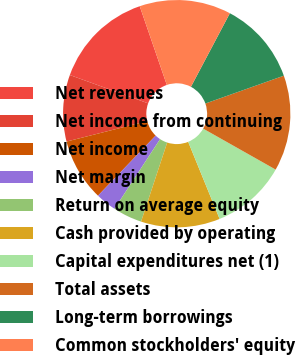<chart> <loc_0><loc_0><loc_500><loc_500><pie_chart><fcel>Net revenues<fcel>Net income from continuing<fcel>Net income<fcel>Net margin<fcel>Return on average equity<fcel>Cash provided by operating<fcel>Capital expenditures net (1)<fcel>Total assets<fcel>Long-term borrowings<fcel>Common stockholders' equity<nl><fcel>14.2%<fcel>9.47%<fcel>8.88%<fcel>2.96%<fcel>4.14%<fcel>11.24%<fcel>10.65%<fcel>13.61%<fcel>11.83%<fcel>13.02%<nl></chart> 